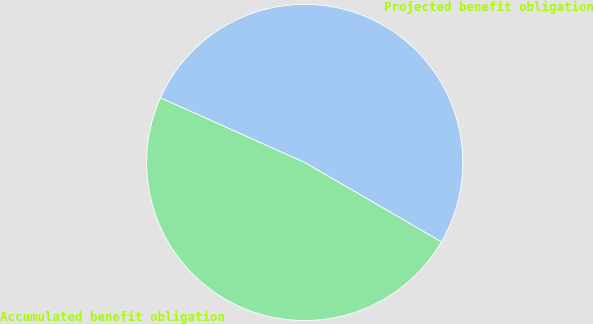Convert chart. <chart><loc_0><loc_0><loc_500><loc_500><pie_chart><fcel>Projected benefit obligation<fcel>Accumulated benefit obligation<nl><fcel>51.67%<fcel>48.33%<nl></chart> 